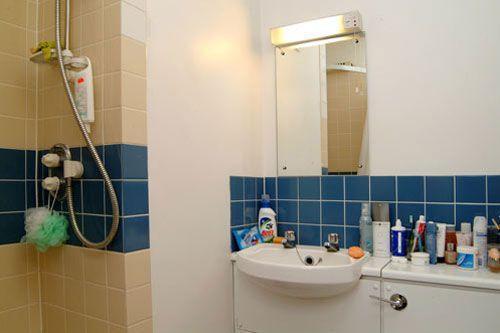How many sinks can be seen?
Give a very brief answer. 1. How many oranges are in the bowl?
Give a very brief answer. 0. 